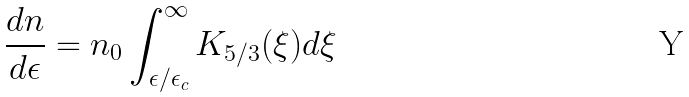<formula> <loc_0><loc_0><loc_500><loc_500>\frac { d n } { d \epsilon } = n _ { 0 } \int ^ { \infty } _ { \epsilon / \epsilon _ { c } } K _ { 5 / 3 } ( \xi ) d \xi</formula> 